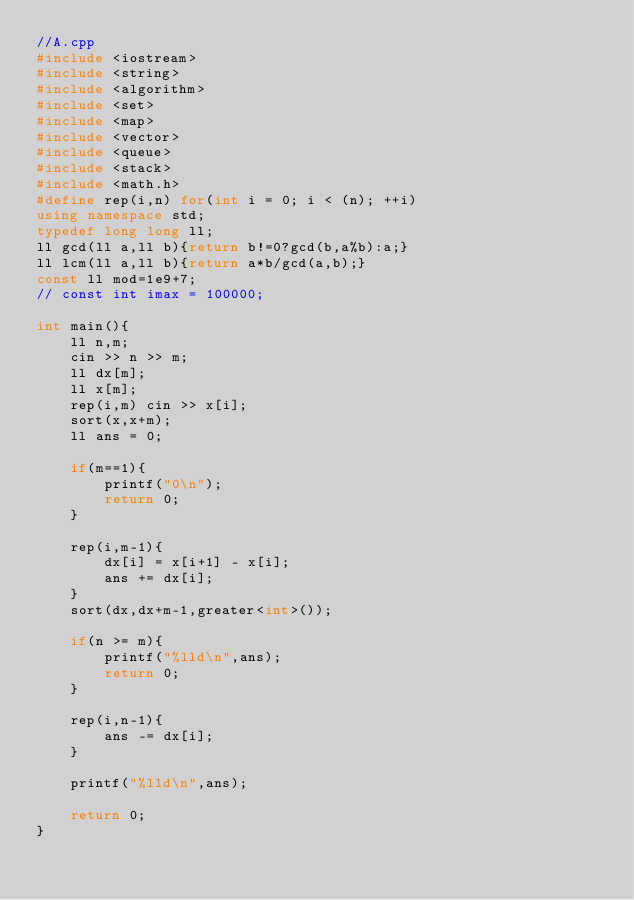<code> <loc_0><loc_0><loc_500><loc_500><_C++_>//A.cpp
#include <iostream>
#include <string>
#include <algorithm>
#include <set>
#include <map>
#include <vector>
#include <queue>
#include <stack>
#include <math.h>
#define rep(i,n) for(int i = 0; i < (n); ++i)
using namespace std;
typedef long long ll;
ll gcd(ll a,ll b){return b!=0?gcd(b,a%b):a;}
ll lcm(ll a,ll b){return a*b/gcd(a,b);}
const ll mod=1e9+7;
// const int imax = 100000;

int main(){
	ll n,m;
	cin >> n >> m;
	ll dx[m];
	ll x[m];
	rep(i,m) cin >> x[i];
	sort(x,x+m);
	ll ans = 0;

	if(m==1){
		printf("0\n");
		return 0;
	}

	rep(i,m-1){
		dx[i] = x[i+1] - x[i];
		ans += dx[i];
	}
	sort(dx,dx+m-1,greater<int>());

	if(n >= m){
		printf("%lld\n",ans);
		return 0;
	}

	rep(i,n-1){
		ans -= dx[i];
	}

	printf("%lld\n",ans);

	return 0;
}</code> 